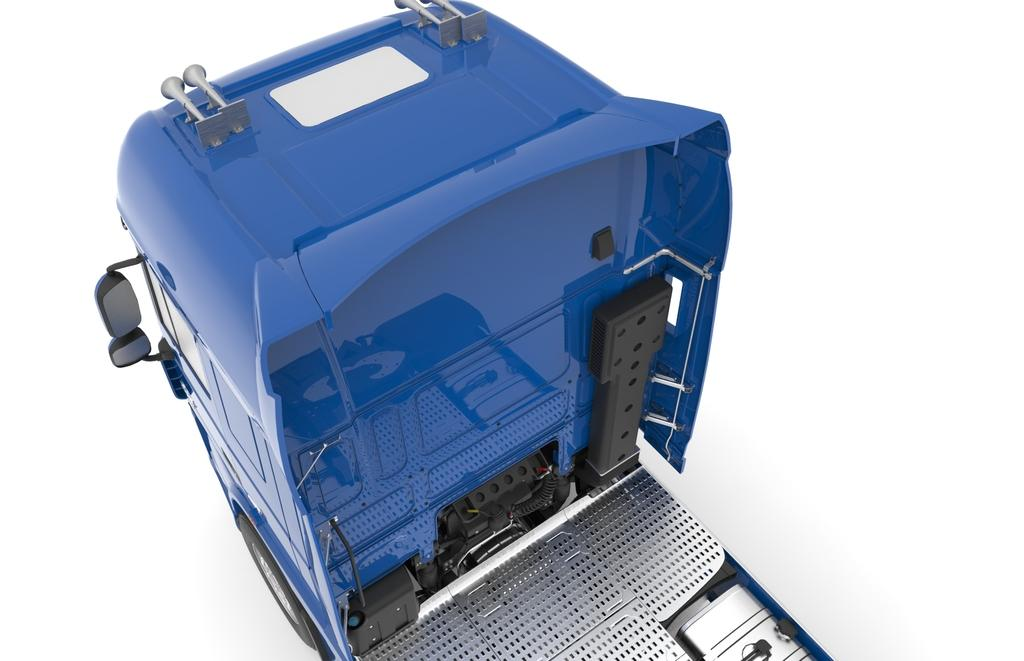What is the main subject of the picture? The main subject of the picture is a truck. Can you describe the color of the truck? The truck is blue. What can be seen in the background of the image? The background of the image is white. What type of jar is sitting on top of the book in the image? There is no jar or book present in the image; it features a blue truck with a white background. 